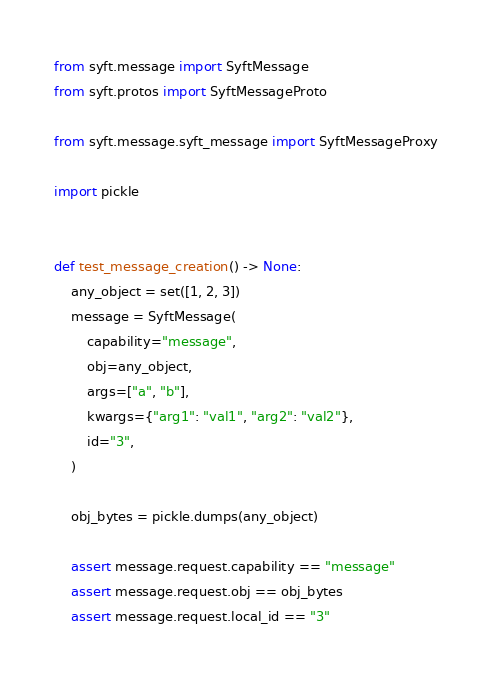<code> <loc_0><loc_0><loc_500><loc_500><_Python_>from syft.message import SyftMessage
from syft.protos import SyftMessageProto

from syft.message.syft_message import SyftMessageProxy

import pickle


def test_message_creation() -> None:
    any_object = set([1, 2, 3])
    message = SyftMessage(
        capability="message",
        obj=any_object,
        args=["a", "b"],
        kwargs={"arg1": "val1", "arg2": "val2"},
        id="3",
    )

    obj_bytes = pickle.dumps(any_object)

    assert message.request.capability == "message"
    assert message.request.obj == obj_bytes
    assert message.request.local_id == "3"</code> 